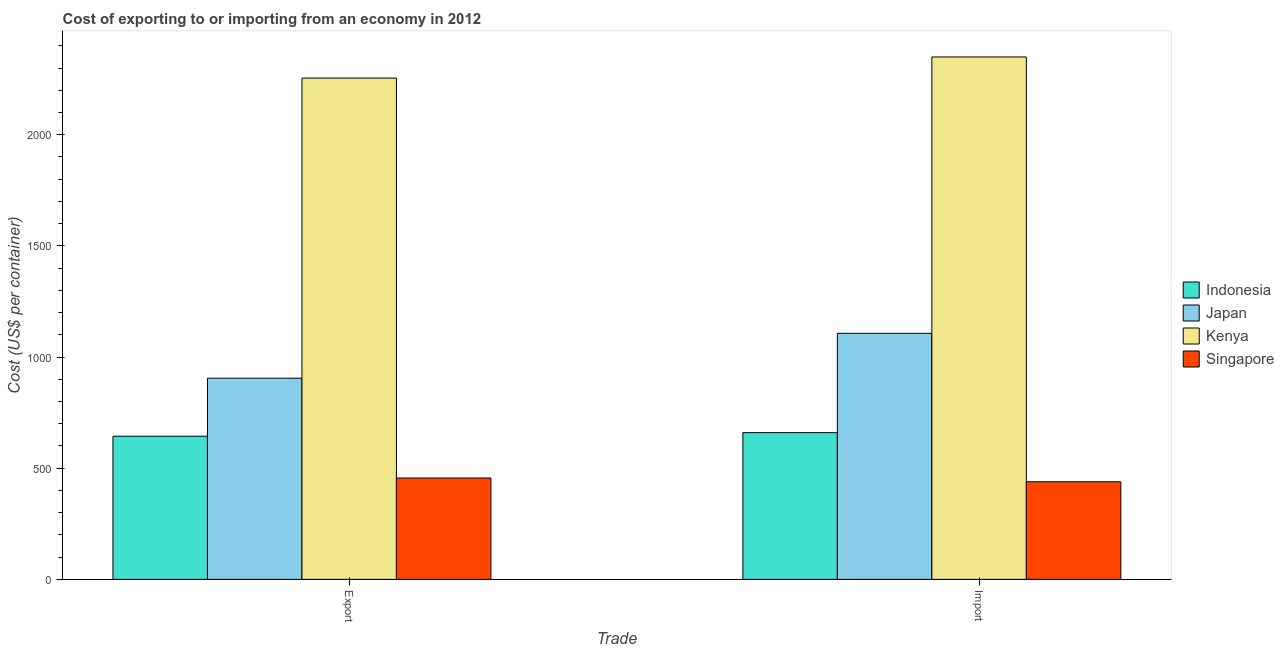How many different coloured bars are there?
Your answer should be very brief. 4. How many groups of bars are there?
Your response must be concise. 2. Are the number of bars per tick equal to the number of legend labels?
Your answer should be very brief. Yes. How many bars are there on the 1st tick from the right?
Give a very brief answer. 4. What is the label of the 1st group of bars from the left?
Give a very brief answer. Export. What is the export cost in Singapore?
Ensure brevity in your answer.  456. Across all countries, what is the maximum import cost?
Give a very brief answer. 2350. Across all countries, what is the minimum export cost?
Keep it short and to the point. 456. In which country was the export cost maximum?
Your answer should be very brief. Kenya. In which country was the export cost minimum?
Provide a succinct answer. Singapore. What is the total import cost in the graph?
Make the answer very short. 4556. What is the difference between the export cost in Japan and that in Kenya?
Your answer should be very brief. -1350. What is the difference between the export cost in Indonesia and the import cost in Singapore?
Provide a succinct answer. 205. What is the average import cost per country?
Give a very brief answer. 1139. What is the difference between the export cost and import cost in Singapore?
Ensure brevity in your answer.  17. What is the ratio of the export cost in Singapore to that in Indonesia?
Provide a short and direct response. 0.71. Is the import cost in Japan less than that in Indonesia?
Make the answer very short. No. Are all the bars in the graph horizontal?
Keep it short and to the point. No. How many countries are there in the graph?
Your answer should be compact. 4. What is the difference between two consecutive major ticks on the Y-axis?
Offer a very short reply. 500. Does the graph contain any zero values?
Make the answer very short. No. Does the graph contain grids?
Give a very brief answer. No. How many legend labels are there?
Offer a very short reply. 4. What is the title of the graph?
Offer a terse response. Cost of exporting to or importing from an economy in 2012. Does "Curacao" appear as one of the legend labels in the graph?
Offer a terse response. No. What is the label or title of the X-axis?
Offer a terse response. Trade. What is the label or title of the Y-axis?
Give a very brief answer. Cost (US$ per container). What is the Cost (US$ per container) in Indonesia in Export?
Your answer should be compact. 644. What is the Cost (US$ per container) of Japan in Export?
Your response must be concise. 905. What is the Cost (US$ per container) in Kenya in Export?
Your answer should be very brief. 2255. What is the Cost (US$ per container) in Singapore in Export?
Your answer should be compact. 456. What is the Cost (US$ per container) of Indonesia in Import?
Keep it short and to the point. 660. What is the Cost (US$ per container) of Japan in Import?
Ensure brevity in your answer.  1107. What is the Cost (US$ per container) of Kenya in Import?
Offer a terse response. 2350. What is the Cost (US$ per container) of Singapore in Import?
Keep it short and to the point. 439. Across all Trade, what is the maximum Cost (US$ per container) in Indonesia?
Offer a terse response. 660. Across all Trade, what is the maximum Cost (US$ per container) in Japan?
Provide a succinct answer. 1107. Across all Trade, what is the maximum Cost (US$ per container) in Kenya?
Your answer should be very brief. 2350. Across all Trade, what is the maximum Cost (US$ per container) in Singapore?
Your answer should be compact. 456. Across all Trade, what is the minimum Cost (US$ per container) of Indonesia?
Your answer should be compact. 644. Across all Trade, what is the minimum Cost (US$ per container) of Japan?
Your answer should be very brief. 905. Across all Trade, what is the minimum Cost (US$ per container) of Kenya?
Give a very brief answer. 2255. Across all Trade, what is the minimum Cost (US$ per container) in Singapore?
Ensure brevity in your answer.  439. What is the total Cost (US$ per container) of Indonesia in the graph?
Your response must be concise. 1304. What is the total Cost (US$ per container) of Japan in the graph?
Keep it short and to the point. 2012. What is the total Cost (US$ per container) of Kenya in the graph?
Your answer should be compact. 4605. What is the total Cost (US$ per container) in Singapore in the graph?
Give a very brief answer. 895. What is the difference between the Cost (US$ per container) in Japan in Export and that in Import?
Offer a terse response. -202. What is the difference between the Cost (US$ per container) of Kenya in Export and that in Import?
Your answer should be compact. -95. What is the difference between the Cost (US$ per container) of Indonesia in Export and the Cost (US$ per container) of Japan in Import?
Make the answer very short. -463. What is the difference between the Cost (US$ per container) of Indonesia in Export and the Cost (US$ per container) of Kenya in Import?
Provide a succinct answer. -1706. What is the difference between the Cost (US$ per container) of Indonesia in Export and the Cost (US$ per container) of Singapore in Import?
Your answer should be very brief. 205. What is the difference between the Cost (US$ per container) of Japan in Export and the Cost (US$ per container) of Kenya in Import?
Your answer should be compact. -1445. What is the difference between the Cost (US$ per container) in Japan in Export and the Cost (US$ per container) in Singapore in Import?
Give a very brief answer. 466. What is the difference between the Cost (US$ per container) of Kenya in Export and the Cost (US$ per container) of Singapore in Import?
Provide a short and direct response. 1816. What is the average Cost (US$ per container) in Indonesia per Trade?
Your response must be concise. 652. What is the average Cost (US$ per container) of Japan per Trade?
Offer a very short reply. 1006. What is the average Cost (US$ per container) of Kenya per Trade?
Offer a terse response. 2302.5. What is the average Cost (US$ per container) of Singapore per Trade?
Provide a short and direct response. 447.5. What is the difference between the Cost (US$ per container) of Indonesia and Cost (US$ per container) of Japan in Export?
Keep it short and to the point. -261. What is the difference between the Cost (US$ per container) in Indonesia and Cost (US$ per container) in Kenya in Export?
Offer a terse response. -1611. What is the difference between the Cost (US$ per container) in Indonesia and Cost (US$ per container) in Singapore in Export?
Your answer should be compact. 188. What is the difference between the Cost (US$ per container) of Japan and Cost (US$ per container) of Kenya in Export?
Provide a succinct answer. -1350. What is the difference between the Cost (US$ per container) of Japan and Cost (US$ per container) of Singapore in Export?
Offer a terse response. 449. What is the difference between the Cost (US$ per container) of Kenya and Cost (US$ per container) of Singapore in Export?
Provide a short and direct response. 1799. What is the difference between the Cost (US$ per container) in Indonesia and Cost (US$ per container) in Japan in Import?
Your answer should be compact. -447. What is the difference between the Cost (US$ per container) in Indonesia and Cost (US$ per container) in Kenya in Import?
Your response must be concise. -1690. What is the difference between the Cost (US$ per container) of Indonesia and Cost (US$ per container) of Singapore in Import?
Your answer should be compact. 221. What is the difference between the Cost (US$ per container) of Japan and Cost (US$ per container) of Kenya in Import?
Your response must be concise. -1243. What is the difference between the Cost (US$ per container) in Japan and Cost (US$ per container) in Singapore in Import?
Give a very brief answer. 668. What is the difference between the Cost (US$ per container) of Kenya and Cost (US$ per container) of Singapore in Import?
Keep it short and to the point. 1911. What is the ratio of the Cost (US$ per container) in Indonesia in Export to that in Import?
Provide a succinct answer. 0.98. What is the ratio of the Cost (US$ per container) of Japan in Export to that in Import?
Your answer should be very brief. 0.82. What is the ratio of the Cost (US$ per container) of Kenya in Export to that in Import?
Provide a short and direct response. 0.96. What is the ratio of the Cost (US$ per container) in Singapore in Export to that in Import?
Your response must be concise. 1.04. What is the difference between the highest and the second highest Cost (US$ per container) in Japan?
Make the answer very short. 202. What is the difference between the highest and the second highest Cost (US$ per container) in Singapore?
Ensure brevity in your answer.  17. What is the difference between the highest and the lowest Cost (US$ per container) in Indonesia?
Your answer should be very brief. 16. What is the difference between the highest and the lowest Cost (US$ per container) in Japan?
Ensure brevity in your answer.  202. What is the difference between the highest and the lowest Cost (US$ per container) in Singapore?
Keep it short and to the point. 17. 